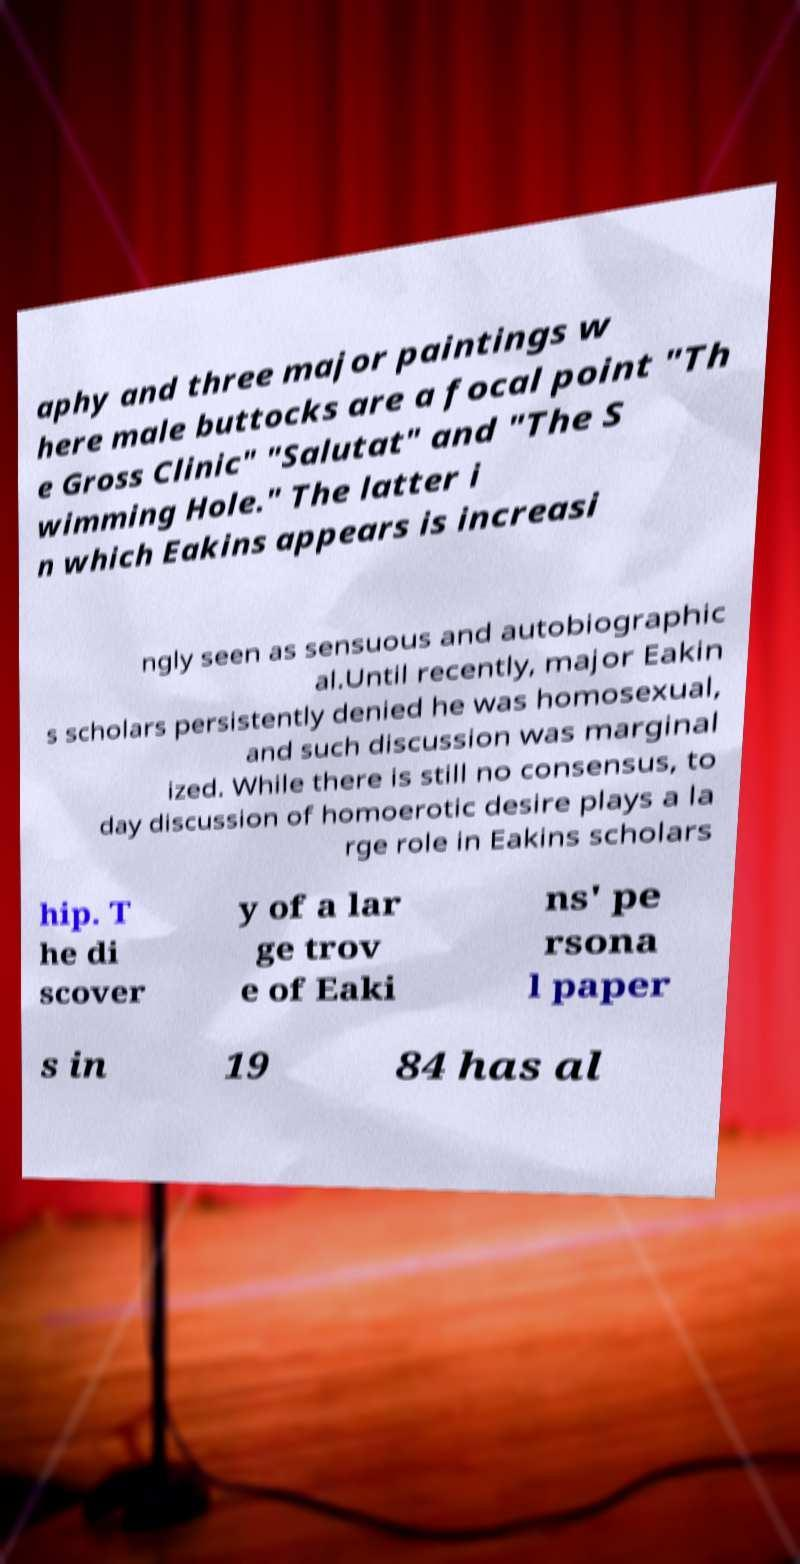Please identify and transcribe the text found in this image. aphy and three major paintings w here male buttocks are a focal point "Th e Gross Clinic" "Salutat" and "The S wimming Hole." The latter i n which Eakins appears is increasi ngly seen as sensuous and autobiographic al.Until recently, major Eakin s scholars persistently denied he was homosexual, and such discussion was marginal ized. While there is still no consensus, to day discussion of homoerotic desire plays a la rge role in Eakins scholars hip. T he di scover y of a lar ge trov e of Eaki ns' pe rsona l paper s in 19 84 has al 